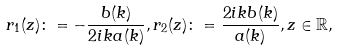Convert formula to latex. <formula><loc_0><loc_0><loc_500><loc_500>r _ { 1 } ( z ) \colon = - \frac { b ( k ) } { 2 i k a ( k ) } , r _ { 2 } ( z ) \colon = \frac { 2 i k b ( k ) } { a ( k ) } , z \in \mathbb { R } ,</formula> 